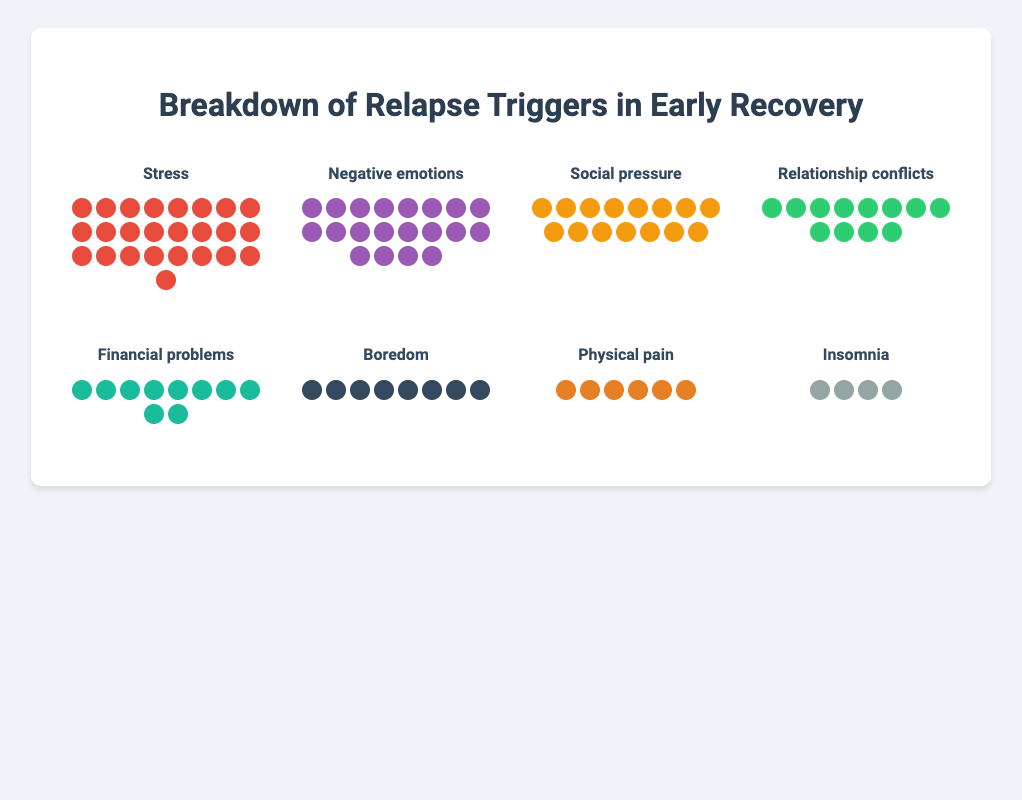Which trigger has the highest count? The highest count can be identified by looking at the number of icons in each category. The "Stress" category has the most icons.
Answer: Stress Which trigger has the lowest count? The lowest count can be identified by looking at the category with the fewest icons. The "Insomnia" category has the fewest icons.
Answer: Insomnia By how much does the count of "Stress" exceed that of "Financial problems"? Subtract the count of "Financial problems" from the count of "Stress" (25 - 10). This results in a difference of 15.
Answer: 15 How many icons are there for "Relationship conflicts" and "Physical pain" combined? Add the number of icons for both "Relationship conflicts" and "Physical pain" (12 + 6). This results in a total of 18 icons.
Answer: 18 What’s the total count of triggers represented in the figure? Sum the counts of all triggers: Stress (25), Negative emotions (20), Social pressure (15), Relationship conflicts (12), Financial problems (10), Boredom (8), Physical pain (6), and Insomnia (4). This results in a total of 100.
Answer: 100 Which two triggers have counts that sum up to 35? Look for two triggers whose individual counts add up to 35. "Negative emotions" (20) and "Social pressure" (15) together sum up to 35.
Answer: Negative emotions and Social pressure Are there more icons for "Social pressure" or "Relationship conflicts"? Compare the counts for "Social pressure" (15) and "Relationship conflicts" (12). There are more icons in "Social pressure" than in "Relationship conflicts".
Answer: Social pressure How many more icons does "Negative emotions" have compared to "Boredom"? Subtract the count of "Boredom" from the count of "Negative emotions" (20 - 8). This results in a difference of 12.
Answer: 12 What percentage of the total triggers does "Physical pain" represent? Divide the "Physical pain" count (6) by the total count of triggers (100) and multiply by 100 to get the percentage (6/100 * 100). This results in 6%.
Answer: 6% 